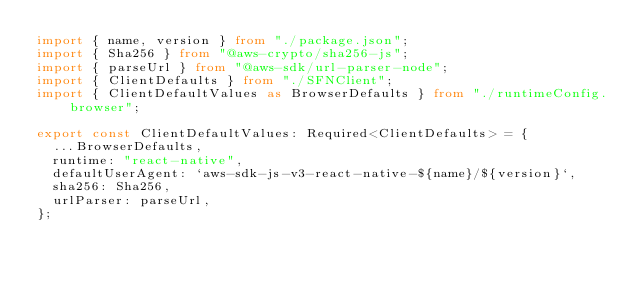<code> <loc_0><loc_0><loc_500><loc_500><_TypeScript_>import { name, version } from "./package.json";
import { Sha256 } from "@aws-crypto/sha256-js";
import { parseUrl } from "@aws-sdk/url-parser-node";
import { ClientDefaults } from "./SFNClient";
import { ClientDefaultValues as BrowserDefaults } from "./runtimeConfig.browser";

export const ClientDefaultValues: Required<ClientDefaults> = {
  ...BrowserDefaults,
  runtime: "react-native",
  defaultUserAgent: `aws-sdk-js-v3-react-native-${name}/${version}`,
  sha256: Sha256,
  urlParser: parseUrl,
};
</code> 